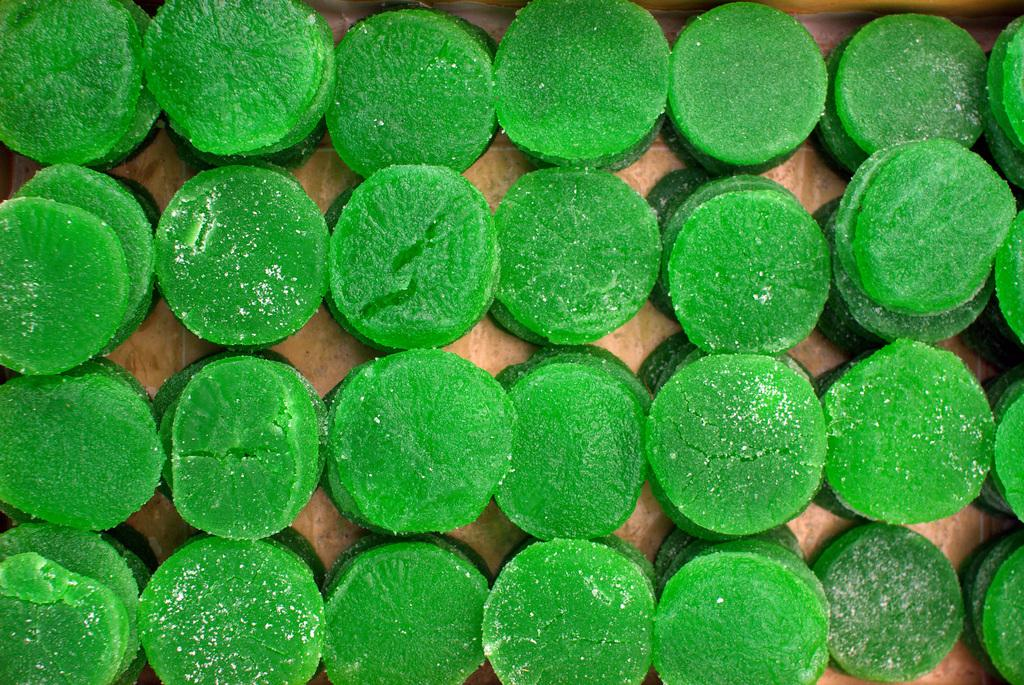What type of confectionery is present in the image? There are candies in the image. Where are the candies located? The candies are on a platform. What type of flowers can be seen growing in the sleet in the image? There are no flowers or sleet present in the image; it features candies on a platform. 